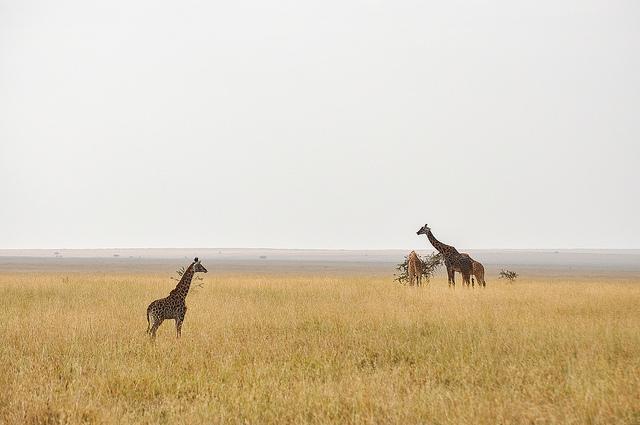How many already fried donuts are there in the image?
Give a very brief answer. 0. 